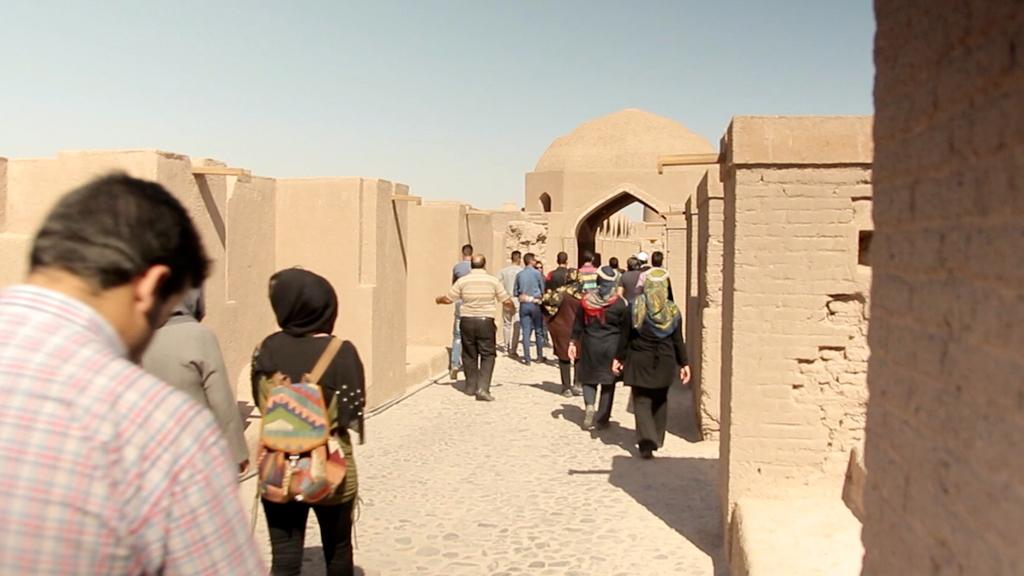What is the main subject of the image? The main subject of the image is a group of people standing. What structure can be seen in the image? There is a fort in the image. What can be seen in the background of the image? The sky is visible in the background of the image. What type of balls are being used by the doctor in the image? There are no balls or doctors present in the image. 